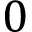Convert formula to latex. <formula><loc_0><loc_0><loc_500><loc_500>0</formula> 